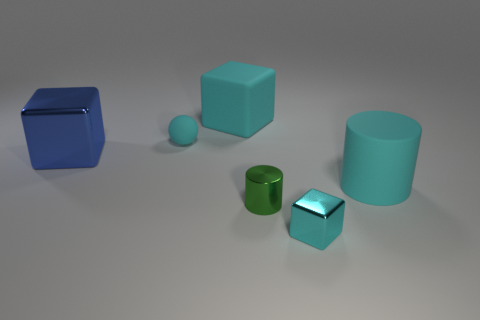Add 3 cyan cylinders. How many objects exist? 9 Subtract all cylinders. How many objects are left? 4 Add 6 big blue shiny cubes. How many big blue shiny cubes are left? 7 Add 1 large blue blocks. How many large blue blocks exist? 2 Subtract 0 brown cubes. How many objects are left? 6 Subtract all blue shiny cubes. Subtract all cyan things. How many objects are left? 1 